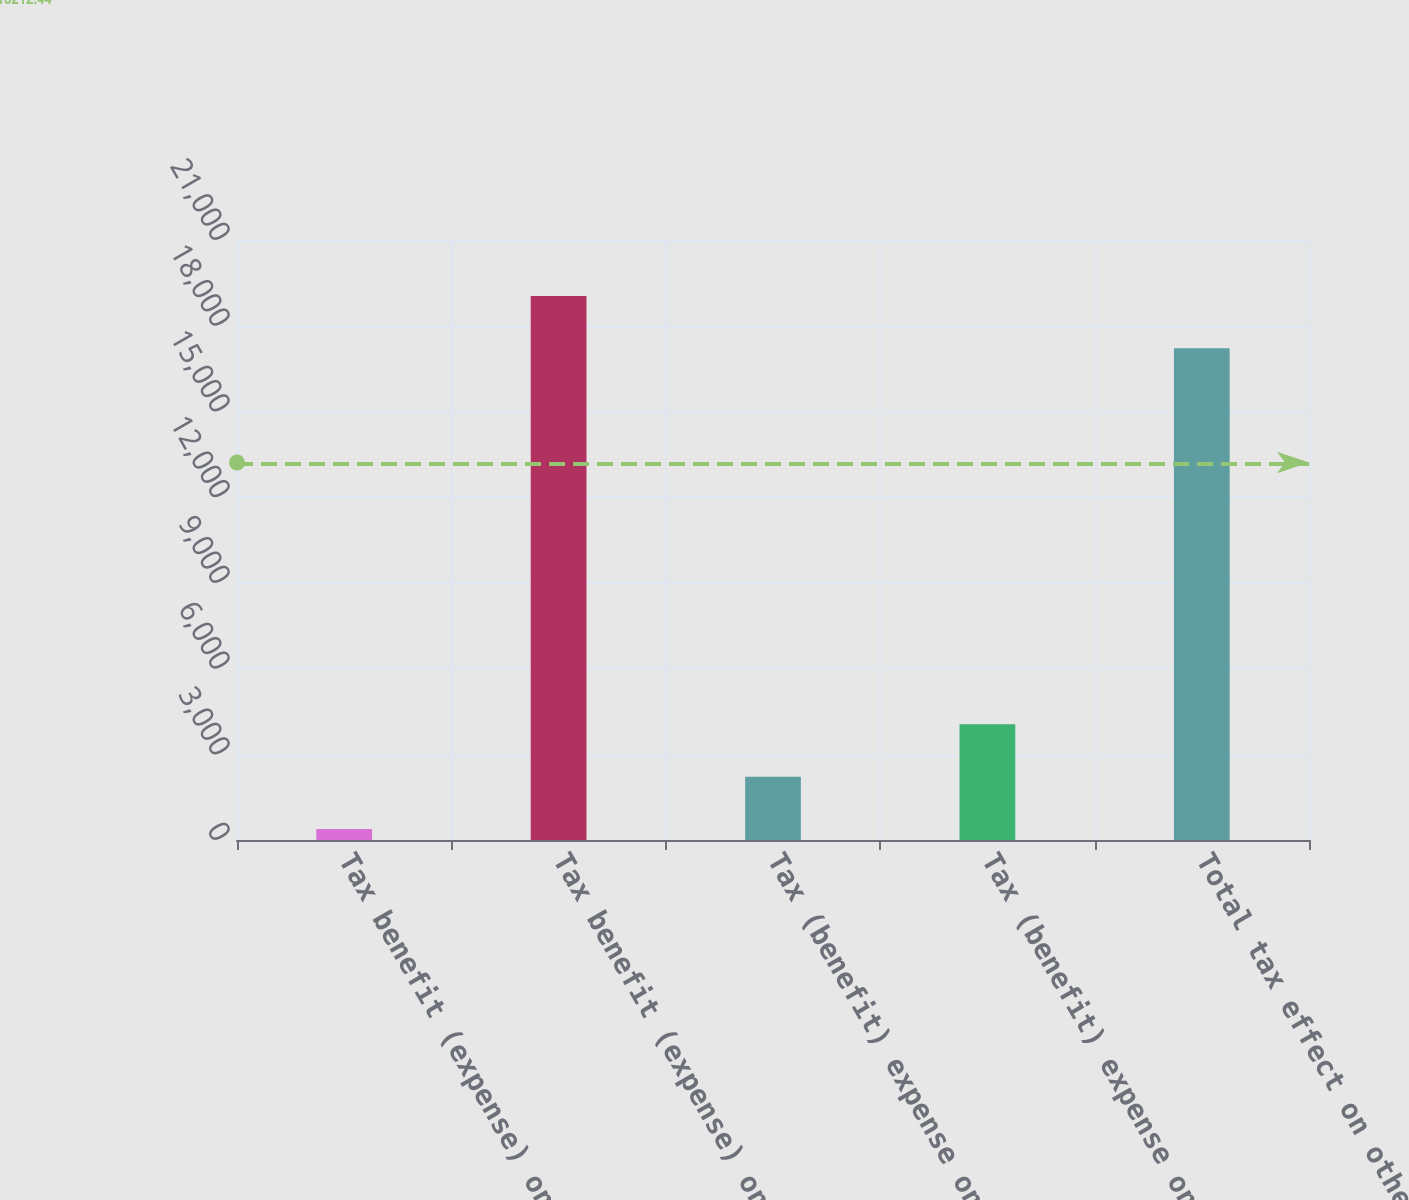Convert chart to OTSL. <chart><loc_0><loc_0><loc_500><loc_500><bar_chart><fcel>Tax benefit (expense) on cash<fcel>Tax benefit (expense) on<fcel>Tax (benefit) expense on cash<fcel>Tax (benefit) expense on<fcel>Total tax effect on other<nl><fcel>384<fcel>19043<fcel>2217<fcel>4050<fcel>17210<nl></chart> 